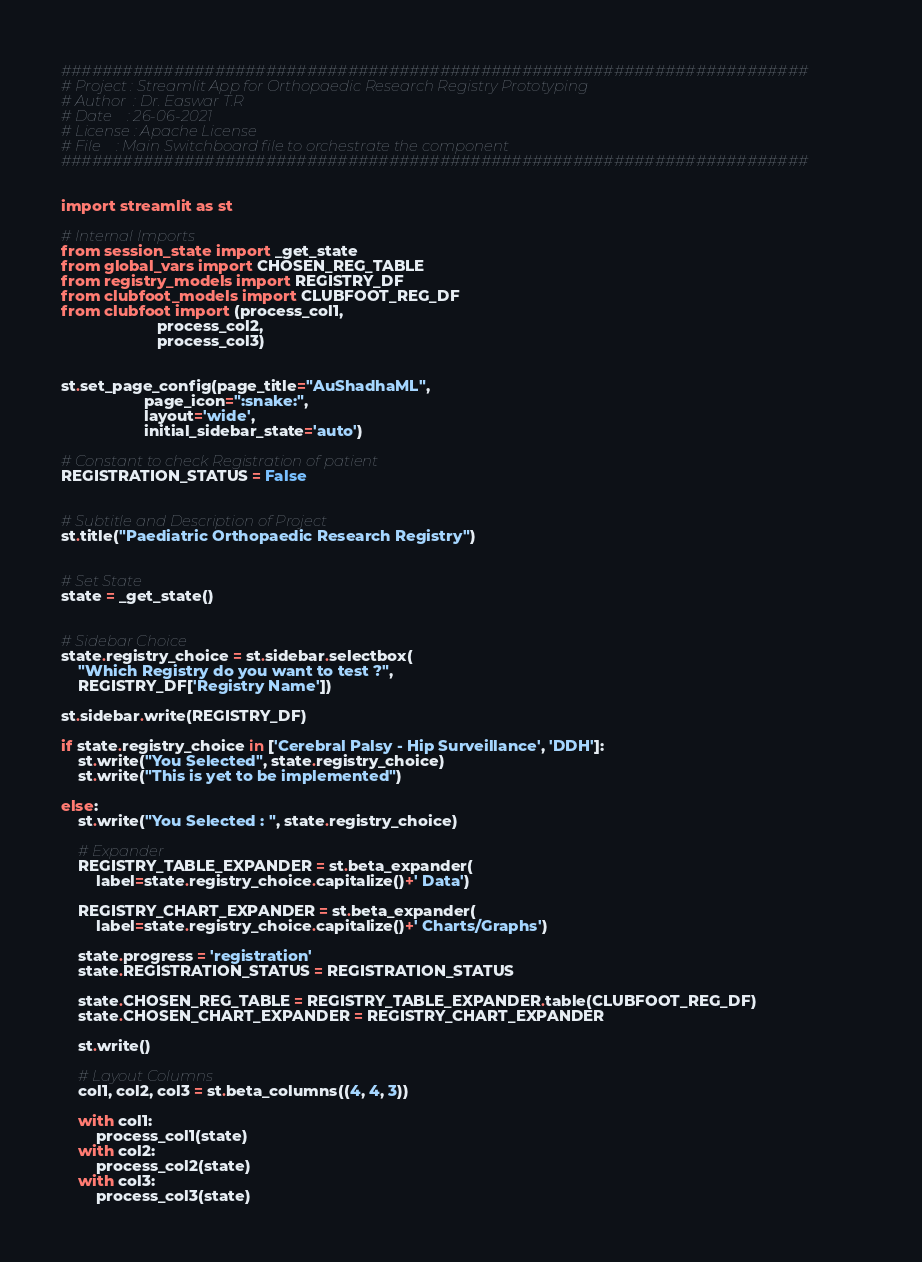Convert code to text. <code><loc_0><loc_0><loc_500><loc_500><_Python_>#########################################################################
# Project : Streamlit App for Orthopaedic Research Registry Prototyping
# Author  : Dr. Easwar T.R
# Date    : 26-06-2021
# License : Apache License
# File    : Main Switchboard file to orchestrate the component
#########################################################################


import streamlit as st

# Internal Imports
from session_state import _get_state
from global_vars import CHOSEN_REG_TABLE
from registry_models import REGISTRY_DF
from clubfoot_models import CLUBFOOT_REG_DF
from clubfoot import (process_col1,
                      process_col2,
                      process_col3)


st.set_page_config(page_title="AuShadhaML",
                   page_icon=":snake:",
                   layout='wide',
                   initial_sidebar_state='auto')

# Constant to check Registration of patient
REGISTRATION_STATUS = False


# Subtitle and Description of Project
st.title("Paediatric Orthopaedic Research Registry")


# Set State
state = _get_state()


# Sidebar Choice
state.registry_choice = st.sidebar.selectbox(
    "Which Registry do you want to test ?",
    REGISTRY_DF['Registry Name'])

st.sidebar.write(REGISTRY_DF)

if state.registry_choice in ['Cerebral Palsy - Hip Surveillance', 'DDH']:
    st.write("You Selected", state.registry_choice)
    st.write("This is yet to be implemented")

else:
    st.write("You Selected : ", state.registry_choice)

    # Expander
    REGISTRY_TABLE_EXPANDER = st.beta_expander(
        label=state.registry_choice.capitalize()+' Data')

    REGISTRY_CHART_EXPANDER = st.beta_expander(
        label=state.registry_choice.capitalize()+' Charts/Graphs')

    state.progress = 'registration'
    state.REGISTRATION_STATUS = REGISTRATION_STATUS

    state.CHOSEN_REG_TABLE = REGISTRY_TABLE_EXPANDER.table(CLUBFOOT_REG_DF)
    state.CHOSEN_CHART_EXPANDER = REGISTRY_CHART_EXPANDER

    st.write()

    # Layout Columns
    col1, col2, col3 = st.beta_columns((4, 4, 3))

    with col1:
        process_col1(state)
    with col2:
        process_col2(state)
    with col3:
        process_col3(state)
</code> 